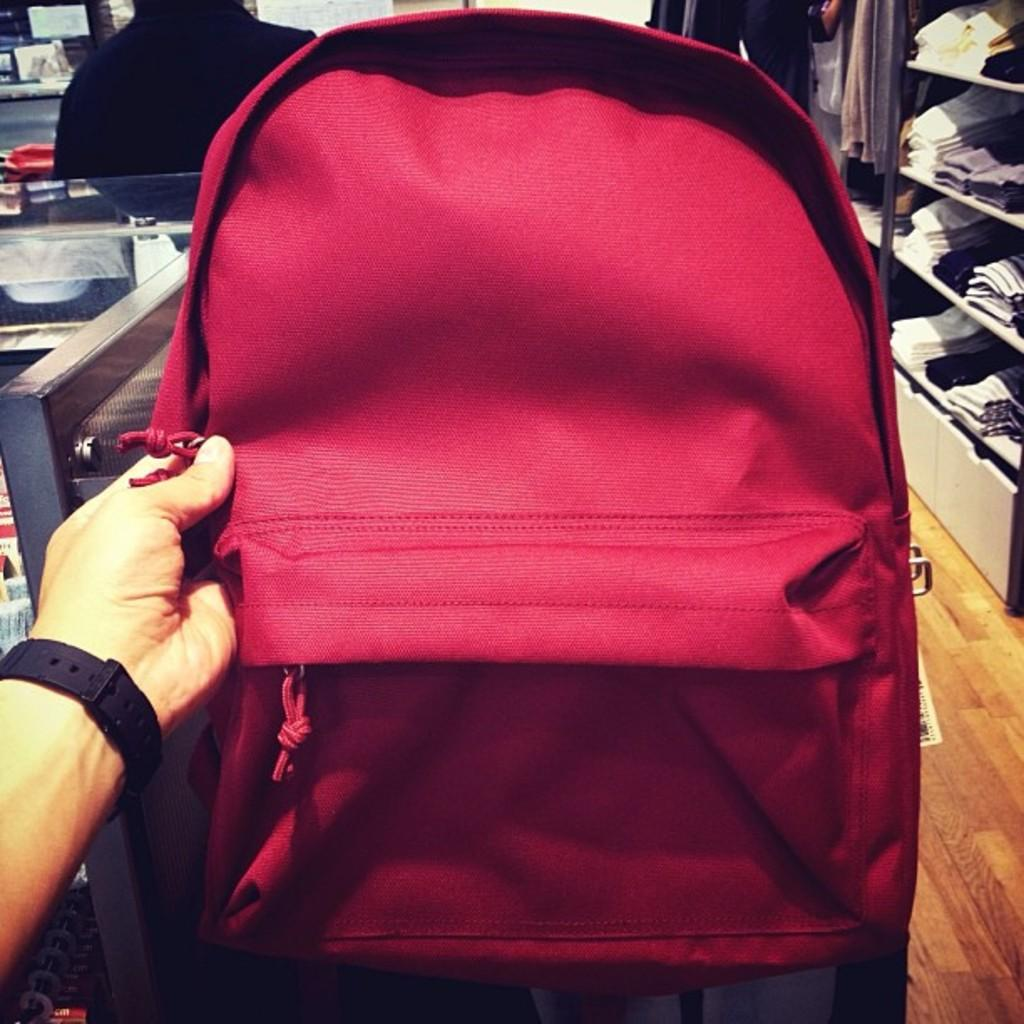What is present in the image? There is a person in the image. What is the person holding? The person is holding a bag. How many fingers can be seen holding the cable in the image? There is no cable present in the image, and therefore no fingers holding it. 